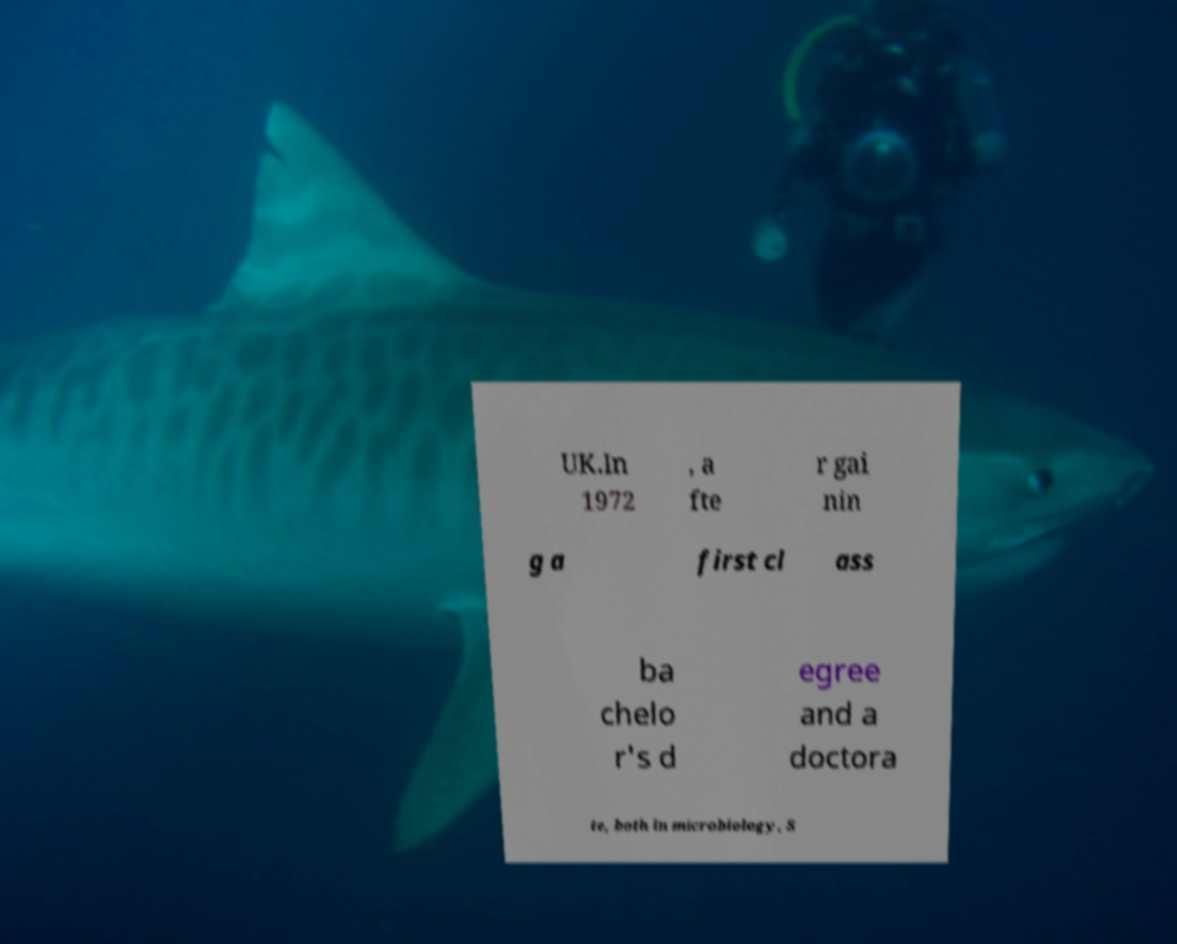Can you accurately transcribe the text from the provided image for me? UK.In 1972 , a fte r gai nin g a first cl ass ba chelo r's d egree and a doctora te, both in microbiology, S 